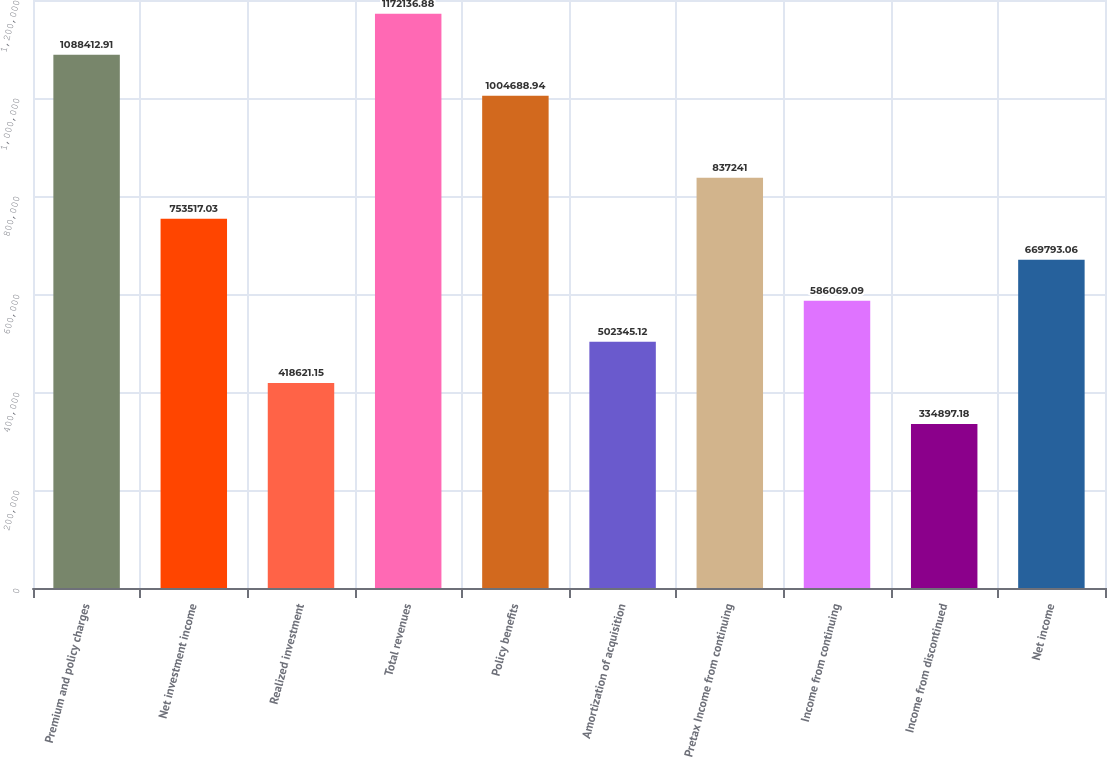Convert chart to OTSL. <chart><loc_0><loc_0><loc_500><loc_500><bar_chart><fcel>Premium and policy charges<fcel>Net investment income<fcel>Realized investment<fcel>Total revenues<fcel>Policy benefits<fcel>Amortization of acquisition<fcel>Pretax Income from continuing<fcel>Income from continuing<fcel>Income from discontinued<fcel>Net income<nl><fcel>1.08841e+06<fcel>753517<fcel>418621<fcel>1.17214e+06<fcel>1.00469e+06<fcel>502345<fcel>837241<fcel>586069<fcel>334897<fcel>669793<nl></chart> 